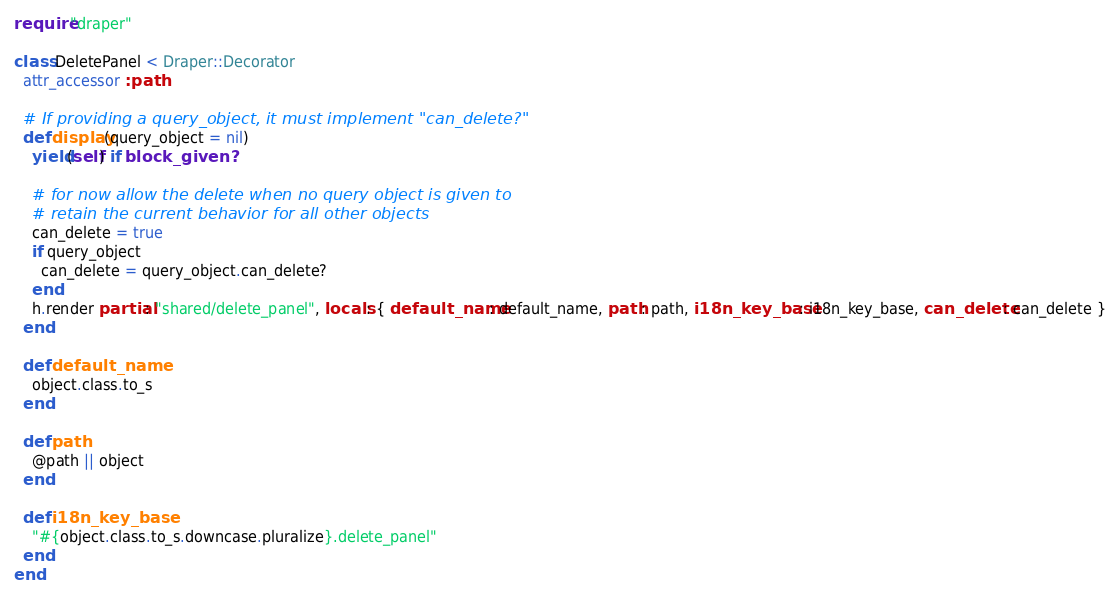Convert code to text. <code><loc_0><loc_0><loc_500><loc_500><_Ruby_>require "draper"

class DeletePanel < Draper::Decorator
  attr_accessor :path

  # If providing a query_object, it must implement "can_delete?"
  def display(query_object = nil)
    yield(self) if block_given?

    # for now allow the delete when no query object is given to
    # retain the current behavior for all other objects
    can_delete = true
    if query_object
      can_delete = query_object.can_delete?
    end
    h.render partial: "shared/delete_panel", locals: { default_name: default_name, path: path, i18n_key_base: i18n_key_base, can_delete: can_delete }
  end

  def default_name
    object.class.to_s
  end

  def path
    @path || object
  end

  def i18n_key_base
    "#{object.class.to_s.downcase.pluralize}.delete_panel"
  end
end
</code> 